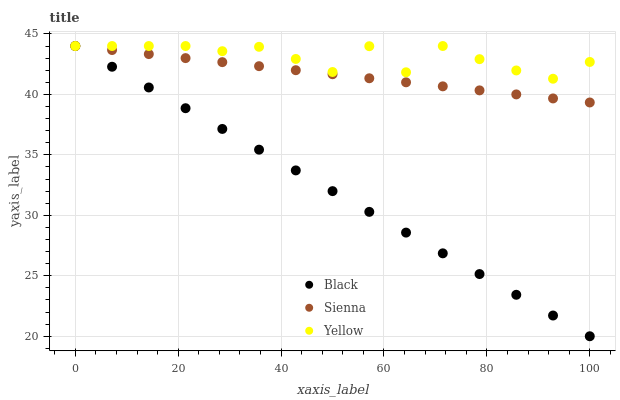Does Black have the minimum area under the curve?
Answer yes or no. Yes. Does Yellow have the maximum area under the curve?
Answer yes or no. Yes. Does Yellow have the minimum area under the curve?
Answer yes or no. No. Does Black have the maximum area under the curve?
Answer yes or no. No. Is Sienna the smoothest?
Answer yes or no. Yes. Is Yellow the roughest?
Answer yes or no. Yes. Is Black the smoothest?
Answer yes or no. No. Is Black the roughest?
Answer yes or no. No. Does Black have the lowest value?
Answer yes or no. Yes. Does Yellow have the lowest value?
Answer yes or no. No. Does Yellow have the highest value?
Answer yes or no. Yes. Does Yellow intersect Sienna?
Answer yes or no. Yes. Is Yellow less than Sienna?
Answer yes or no. No. Is Yellow greater than Sienna?
Answer yes or no. No. 